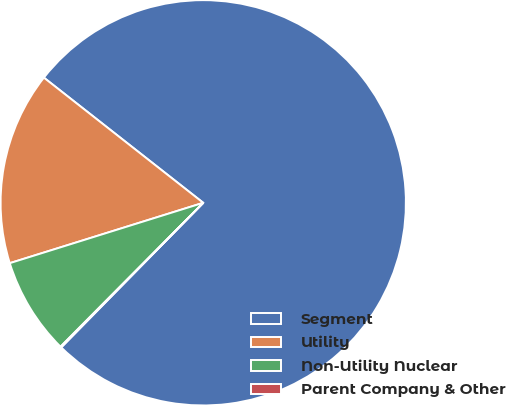<chart> <loc_0><loc_0><loc_500><loc_500><pie_chart><fcel>Segment<fcel>Utility<fcel>Non-Utility Nuclear<fcel>Parent Company & Other<nl><fcel>76.76%<fcel>15.41%<fcel>7.75%<fcel>0.08%<nl></chart> 